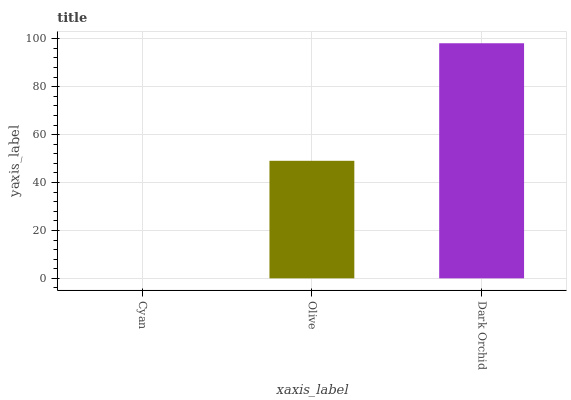Is Cyan the minimum?
Answer yes or no. Yes. Is Dark Orchid the maximum?
Answer yes or no. Yes. Is Olive the minimum?
Answer yes or no. No. Is Olive the maximum?
Answer yes or no. No. Is Olive greater than Cyan?
Answer yes or no. Yes. Is Cyan less than Olive?
Answer yes or no. Yes. Is Cyan greater than Olive?
Answer yes or no. No. Is Olive less than Cyan?
Answer yes or no. No. Is Olive the high median?
Answer yes or no. Yes. Is Olive the low median?
Answer yes or no. Yes. Is Cyan the high median?
Answer yes or no. No. Is Cyan the low median?
Answer yes or no. No. 